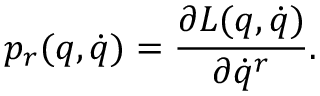<formula> <loc_0><loc_0><loc_500><loc_500>p _ { r } ( q , \dot { q } ) = \frac { \partial L ( q , \dot { q } ) } { \partial \dot { q } ^ { r } } .</formula> 